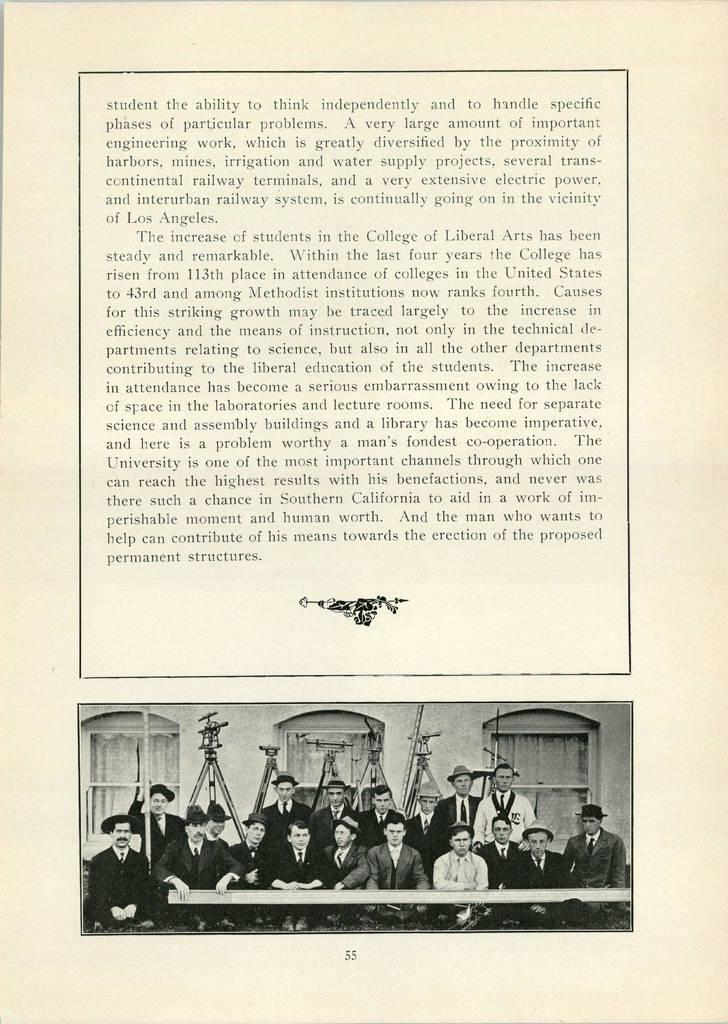What is present on the paper in the image? There is text on the paper in the image. Can you describe the people depicted on the paper? There are persons at the bottom of the paper. What can be seen in the background of the image? There is a wall and windows in the image. What else is visible in the image besides the paper and the background? There are some objects in the image. What is the earth's reaction to the sneeze in the image? There is no sneeze or reference to the earth in the image. 